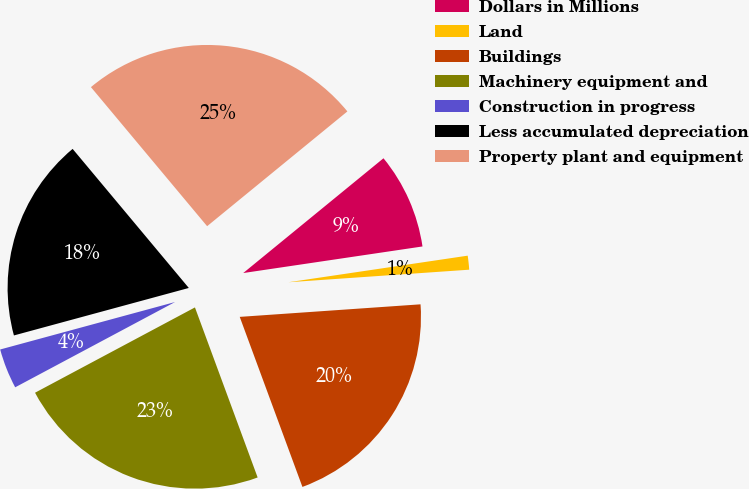Convert chart to OTSL. <chart><loc_0><loc_0><loc_500><loc_500><pie_chart><fcel>Dollars in Millions<fcel>Land<fcel>Buildings<fcel>Machinery equipment and<fcel>Construction in progress<fcel>Less accumulated depreciation<fcel>Property plant and equipment<nl><fcel>8.57%<fcel>1.24%<fcel>20.48%<fcel>22.82%<fcel>3.58%<fcel>18.14%<fcel>25.16%<nl></chart> 